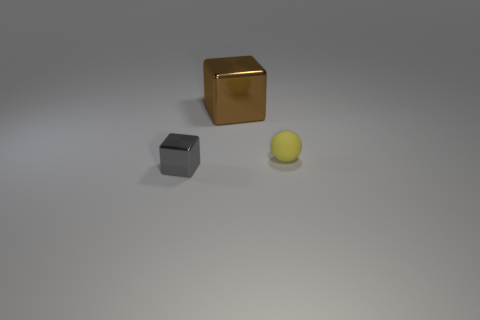Add 2 green things. How many objects exist? 5 Subtract all balls. How many objects are left? 2 Subtract all gray cylinders. How many green cubes are left? 0 Subtract all tiny gray matte objects. Subtract all rubber things. How many objects are left? 2 Add 3 matte spheres. How many matte spheres are left? 4 Add 2 large shiny blocks. How many large shiny blocks exist? 3 Subtract all brown blocks. How many blocks are left? 1 Subtract 1 yellow spheres. How many objects are left? 2 Subtract all brown cubes. Subtract all red cylinders. How many cubes are left? 1 